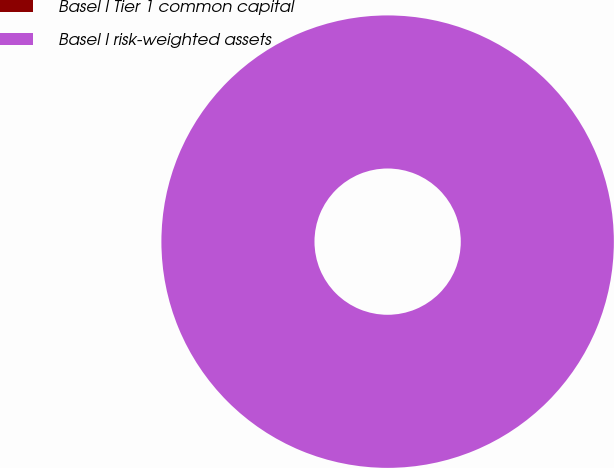Convert chart to OTSL. <chart><loc_0><loc_0><loc_500><loc_500><pie_chart><fcel>Basel I Tier 1 common capital<fcel>Basel I risk-weighted assets<nl><fcel>0.0%<fcel>100.0%<nl></chart> 